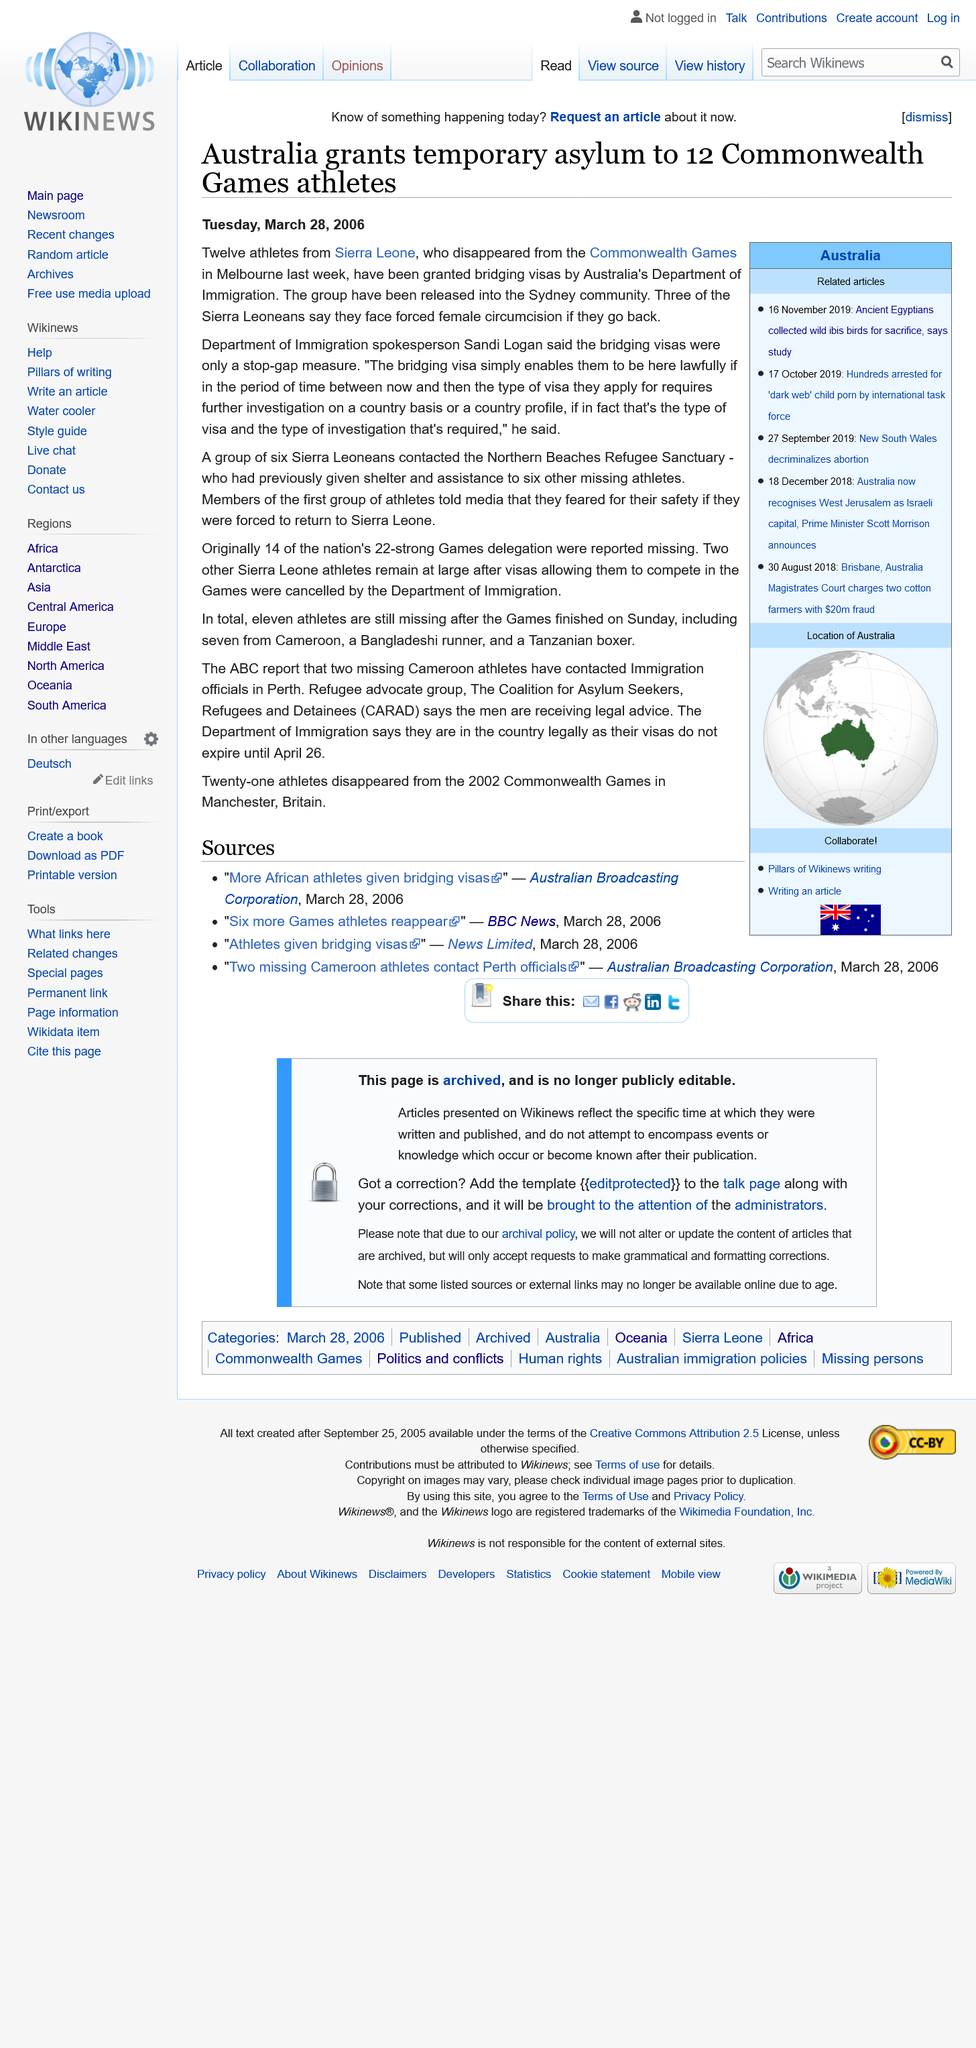Draw attention to some important aspects in this diagram. During the 2006 Commonwealth Games, a total of twelve athletes from Sierra Leone were granted temporary asylum by Australia. In 2006, Australia granted temporary asylum to athletes from Sierra Leone, a country that had recently emerged from a brutal civil war. This decision was controversial, as it drew criticism from some who accused Australia of prioritizing the interests of wealthy and prominent athletes over the needs of the refugees. Despite the backlash, the decision was ultimately upheld by the Australian government, and the athletes were allowed to resettle in the country. Sandi Logan is a spokesperson for the Department of Immigration in Australia. 